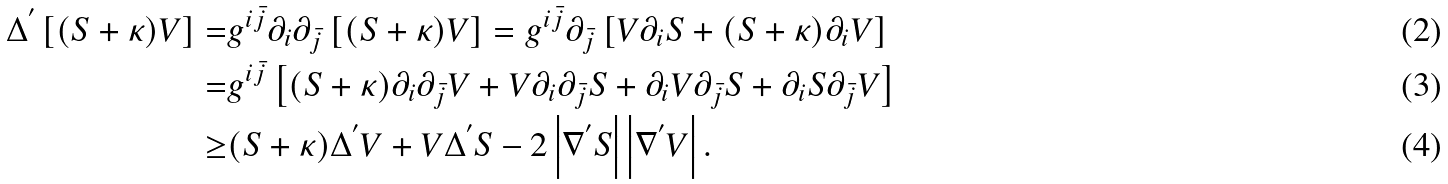<formula> <loc_0><loc_0><loc_500><loc_500>\Delta ^ { ^ { \prime } } \left [ ( S + \kappa ) V \right ] = & g ^ { i \bar { j } } \partial _ { i } \partial _ { \bar { j } } \left [ ( S + \kappa ) V \right ] = g ^ { i \bar { j } } \partial _ { \bar { j } } \left [ V \partial _ { i } S + ( S + \kappa ) \partial _ { i } V \right ] \\ = & g ^ { i \bar { j } } \left [ ( S + \kappa ) \partial _ { i } \partial _ { \bar { j } } V + V \partial _ { i } \partial _ { \bar { j } } S + \partial _ { i } V \partial _ { \bar { j } } S + \partial _ { i } S \partial _ { \bar { j } } V \right ] \\ \geq & ( S + \kappa ) \Delta ^ { ^ { \prime } } V + V \Delta ^ { ^ { \prime } } S - 2 \left | \nabla ^ { ^ { \prime } } S \right | \left | \nabla ^ { ^ { \prime } } V \right | .</formula> 